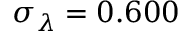Convert formula to latex. <formula><loc_0><loc_0><loc_500><loc_500>\sigma _ { \lambda } = 0 . 6 0 0</formula> 